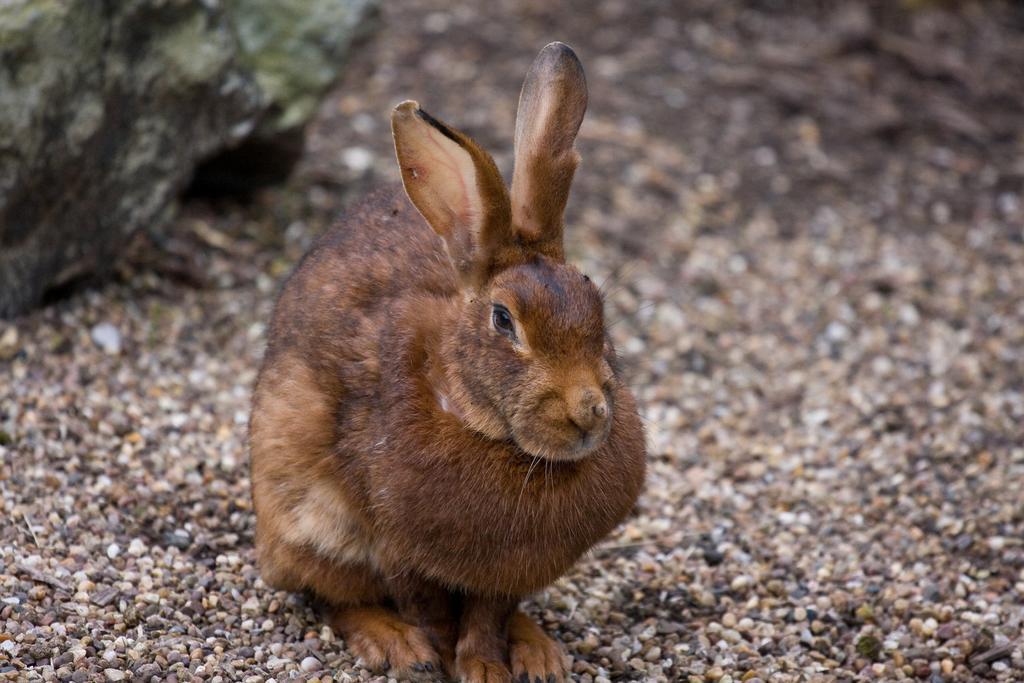Describe this image in one or two sentences. This picture shows a rabbit. It is black and brown in color and we see a rock on the side and few small stones on the ground. 